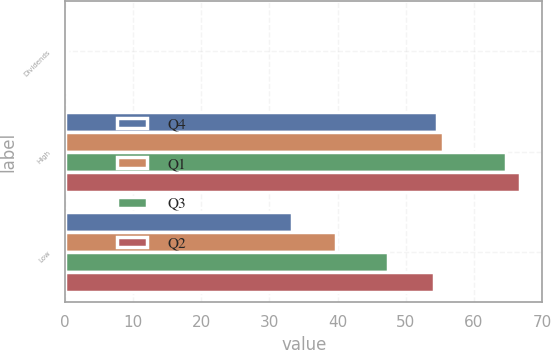<chart> <loc_0><loc_0><loc_500><loc_500><stacked_bar_chart><ecel><fcel>Dividends<fcel>High<fcel>Low<nl><fcel>Q4<fcel>0.27<fcel>54.66<fcel>33.28<nl><fcel>Q1<fcel>0.27<fcel>55.45<fcel>39.82<nl><fcel>Q3<fcel>0.27<fcel>64.75<fcel>47.47<nl><fcel>Q2<fcel>0.27<fcel>66.73<fcel>54.2<nl></chart> 